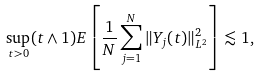Convert formula to latex. <formula><loc_0><loc_0><loc_500><loc_500>\sup _ { t > 0 } ( t \wedge 1 ) E \left [ \frac { 1 } { N } \sum _ { j = 1 } ^ { N } \| Y _ { j } ( t ) \| _ { L ^ { 2 } } ^ { 2 } \right ] \lesssim 1 ,</formula> 